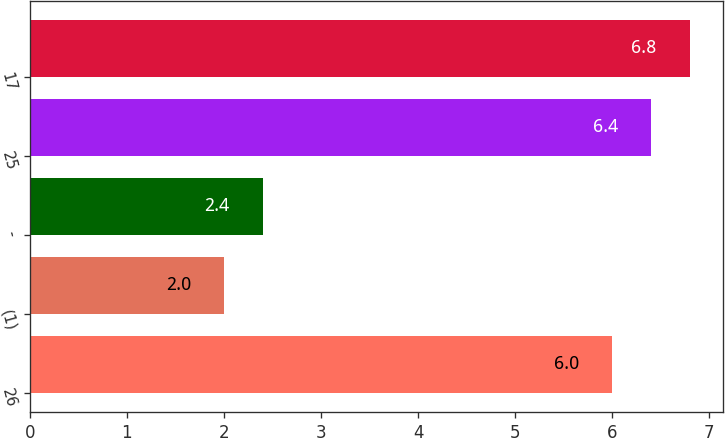Convert chart to OTSL. <chart><loc_0><loc_0><loc_500><loc_500><bar_chart><fcel>26<fcel>(1)<fcel>-<fcel>25<fcel>17<nl><fcel>6<fcel>2<fcel>2.4<fcel>6.4<fcel>6.8<nl></chart> 